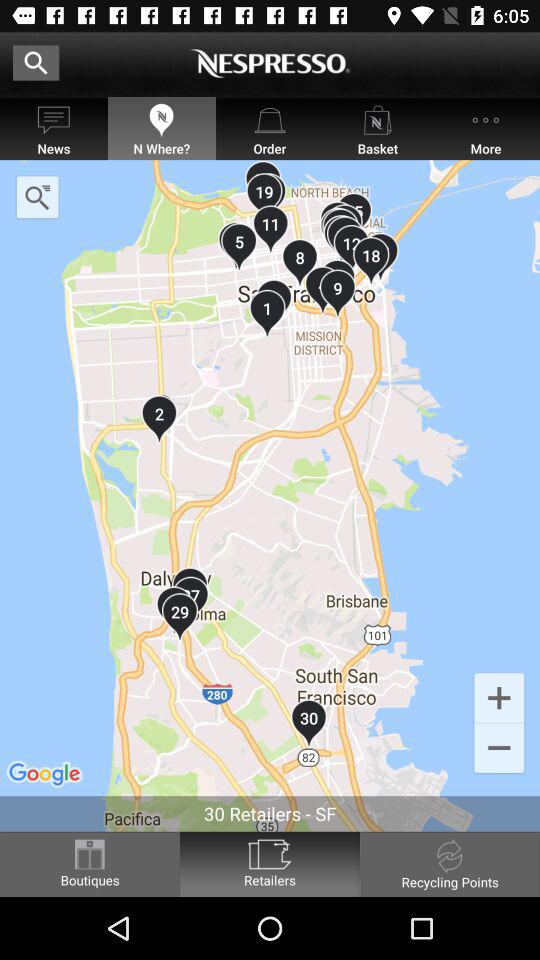How many retailers are shown here? There are 30 retailers shown here. 